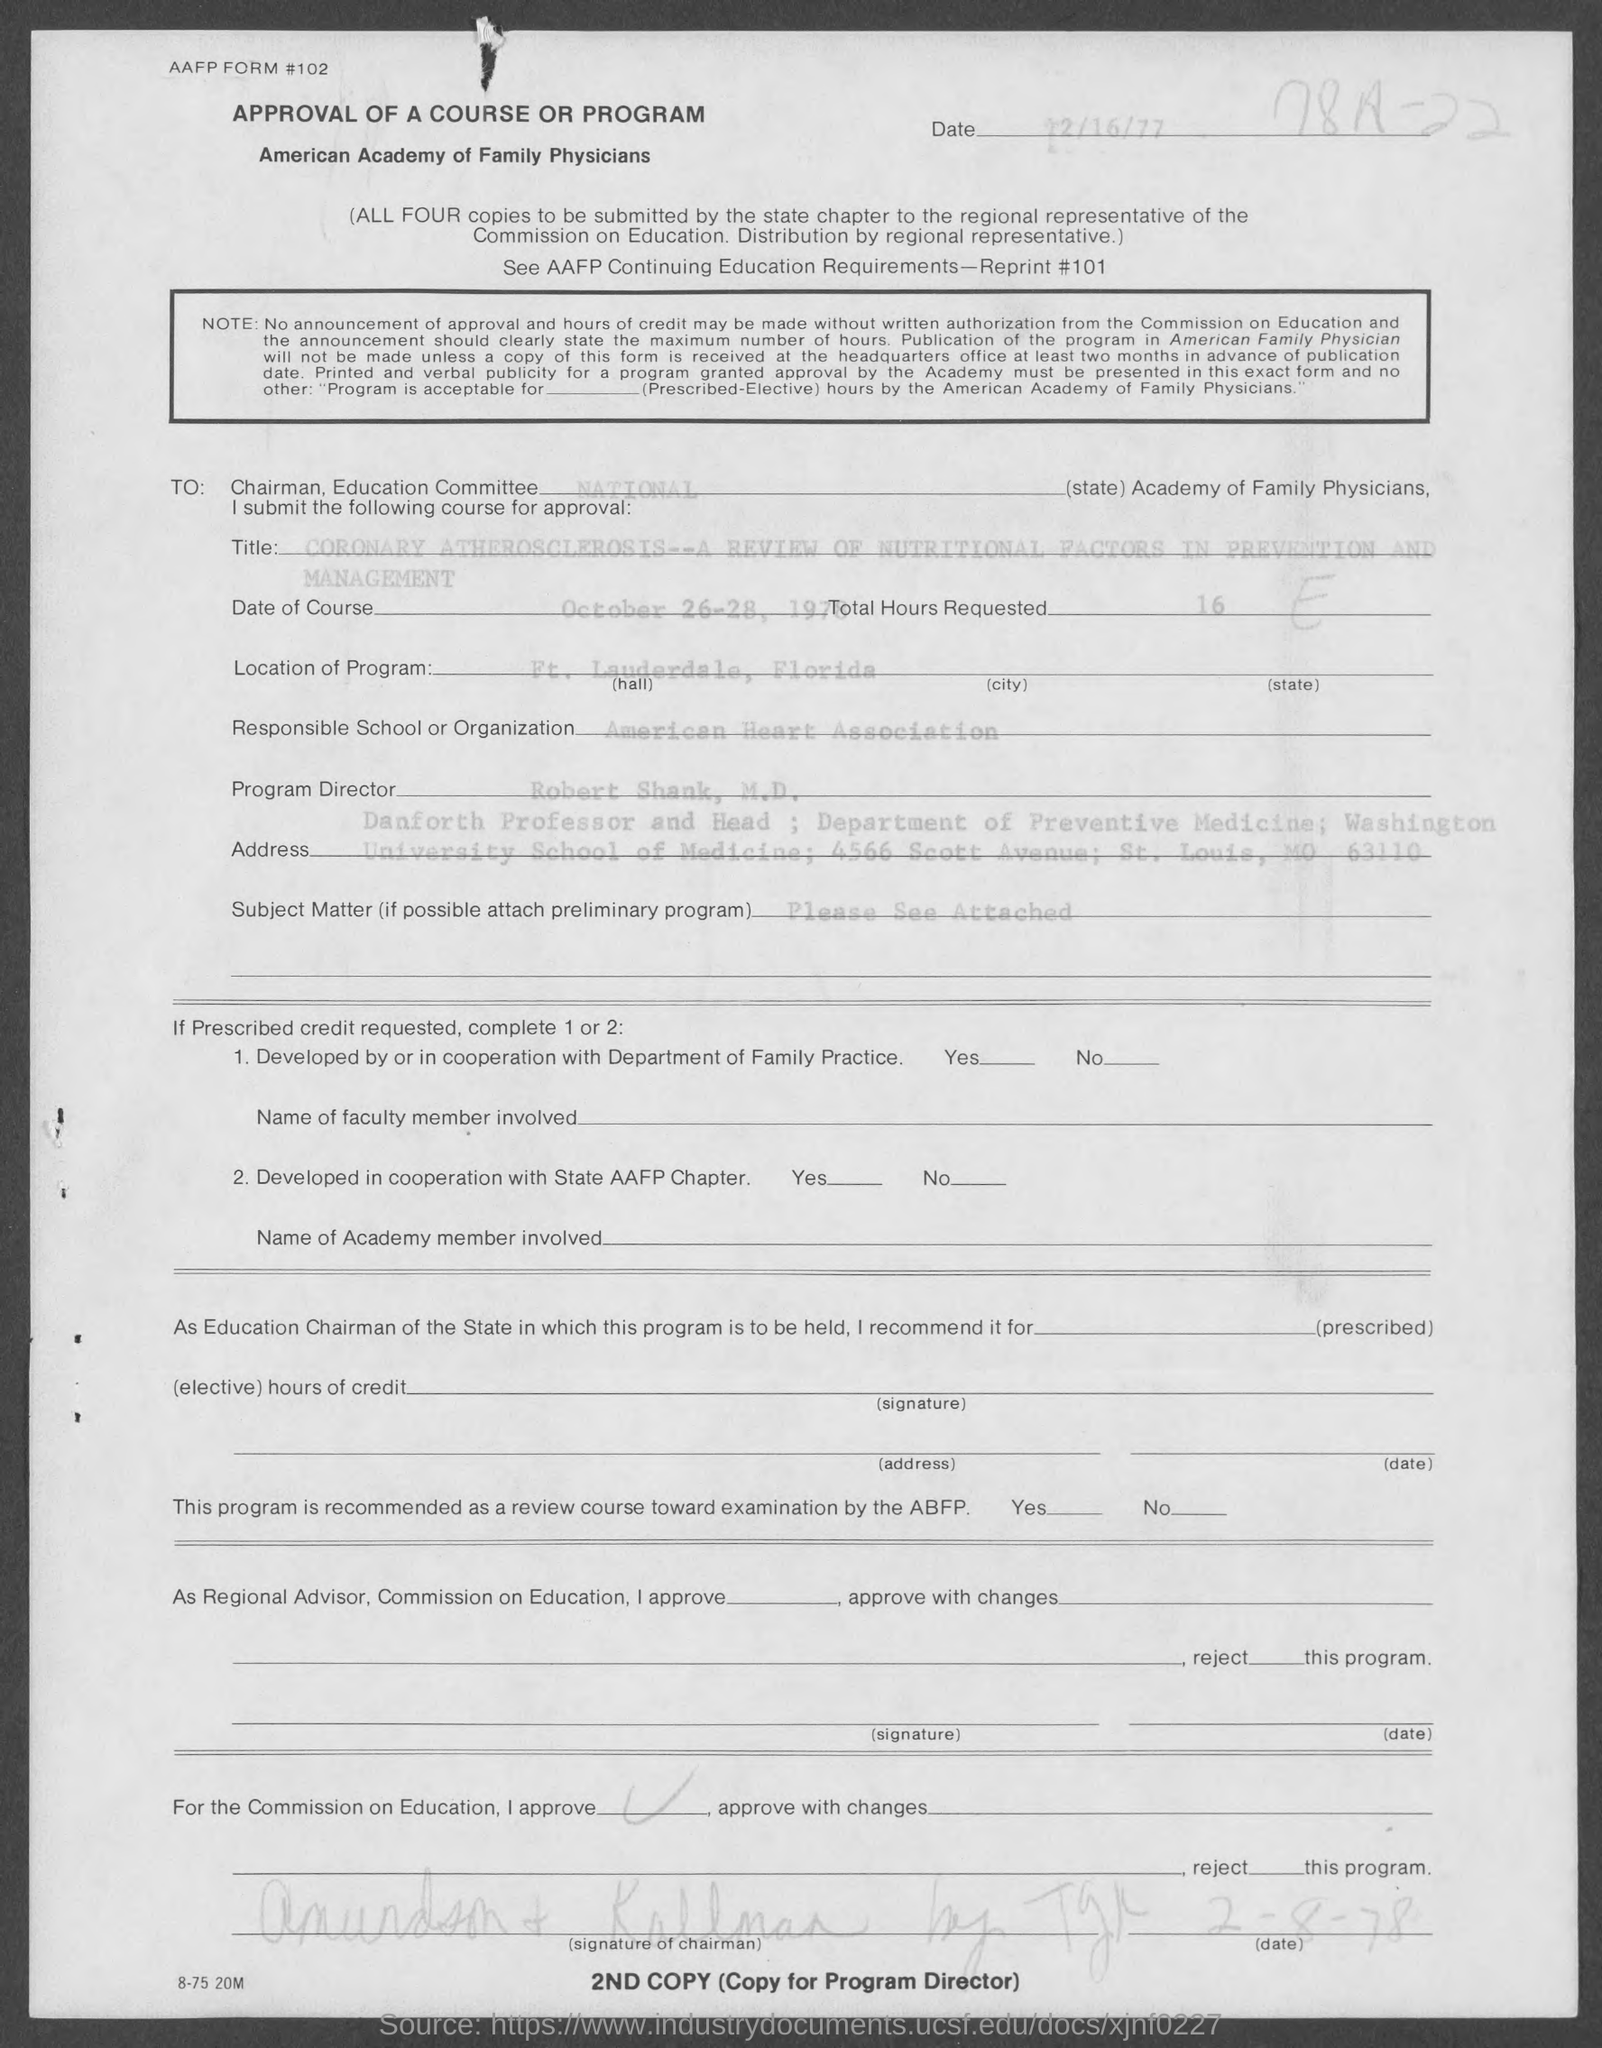What is the date of the document?
Offer a very short reply. 12/16/77. What is the date of course?
Offer a very short reply. October 26-28, 1978. What is the total hours requested?
Offer a terse response. 16. What is the location of program?
Your response must be concise. Ft. Lauderdale, Florida. Who is the program director?
Provide a short and direct response. Robert Shank, M.D. 